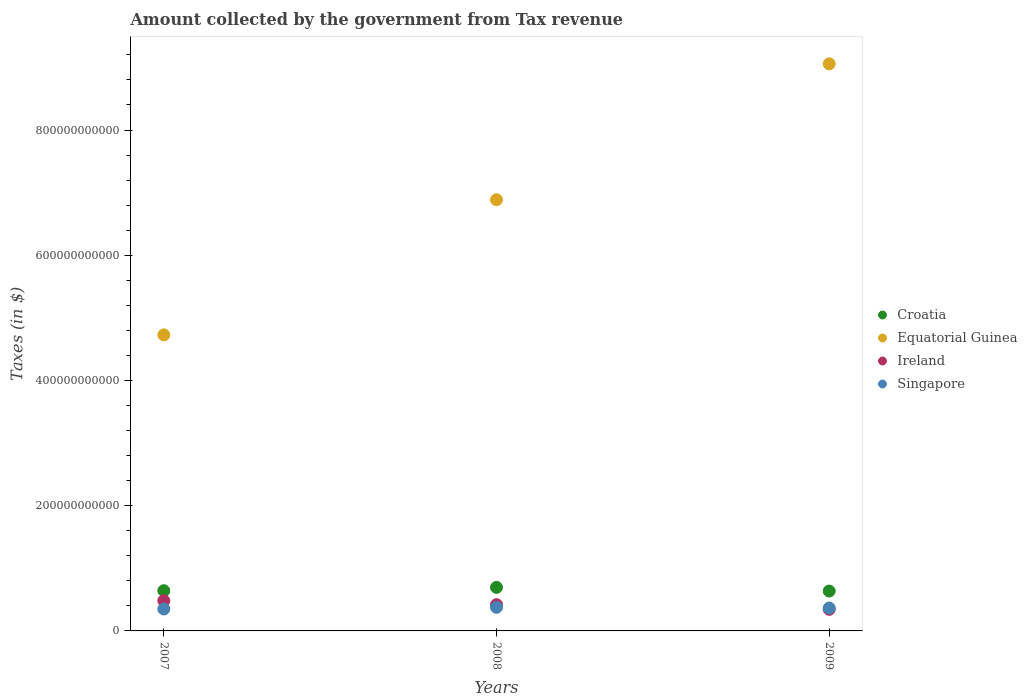What is the amount collected by the government from tax revenue in Singapore in 2009?
Make the answer very short. 3.66e+1. Across all years, what is the maximum amount collected by the government from tax revenue in Equatorial Guinea?
Your answer should be very brief. 9.06e+11. Across all years, what is the minimum amount collected by the government from tax revenue in Singapore?
Ensure brevity in your answer.  3.50e+1. In which year was the amount collected by the government from tax revenue in Ireland maximum?
Provide a short and direct response. 2007. In which year was the amount collected by the government from tax revenue in Ireland minimum?
Provide a succinct answer. 2009. What is the total amount collected by the government from tax revenue in Equatorial Guinea in the graph?
Make the answer very short. 2.07e+12. What is the difference between the amount collected by the government from tax revenue in Ireland in 2007 and that in 2009?
Your answer should be very brief. 1.39e+1. What is the difference between the amount collected by the government from tax revenue in Equatorial Guinea in 2008 and the amount collected by the government from tax revenue in Ireland in 2009?
Offer a very short reply. 6.54e+11. What is the average amount collected by the government from tax revenue in Singapore per year?
Give a very brief answer. 3.64e+1. In the year 2008, what is the difference between the amount collected by the government from tax revenue in Ireland and amount collected by the government from tax revenue in Croatia?
Provide a succinct answer. -2.77e+1. In how many years, is the amount collected by the government from tax revenue in Equatorial Guinea greater than 480000000000 $?
Your response must be concise. 2. What is the ratio of the amount collected by the government from tax revenue in Singapore in 2007 to that in 2009?
Provide a succinct answer. 0.96. Is the amount collected by the government from tax revenue in Ireland in 2007 less than that in 2008?
Provide a short and direct response. No. What is the difference between the highest and the second highest amount collected by the government from tax revenue in Croatia?
Your answer should be compact. 5.34e+09. What is the difference between the highest and the lowest amount collected by the government from tax revenue in Croatia?
Make the answer very short. 5.89e+09. In how many years, is the amount collected by the government from tax revenue in Croatia greater than the average amount collected by the government from tax revenue in Croatia taken over all years?
Your answer should be compact. 1. Is the sum of the amount collected by the government from tax revenue in Equatorial Guinea in 2007 and 2009 greater than the maximum amount collected by the government from tax revenue in Croatia across all years?
Your answer should be very brief. Yes. Is it the case that in every year, the sum of the amount collected by the government from tax revenue in Ireland and amount collected by the government from tax revenue in Equatorial Guinea  is greater than the sum of amount collected by the government from tax revenue in Croatia and amount collected by the government from tax revenue in Singapore?
Ensure brevity in your answer.  Yes. Is it the case that in every year, the sum of the amount collected by the government from tax revenue in Ireland and amount collected by the government from tax revenue in Singapore  is greater than the amount collected by the government from tax revenue in Equatorial Guinea?
Your answer should be compact. No. Is the amount collected by the government from tax revenue in Singapore strictly less than the amount collected by the government from tax revenue in Ireland over the years?
Make the answer very short. No. What is the difference between two consecutive major ticks on the Y-axis?
Your answer should be very brief. 2.00e+11. Are the values on the major ticks of Y-axis written in scientific E-notation?
Offer a terse response. No. Does the graph contain grids?
Your response must be concise. No. Where does the legend appear in the graph?
Ensure brevity in your answer.  Center right. What is the title of the graph?
Your answer should be very brief. Amount collected by the government from Tax revenue. Does "Latin America(all income levels)" appear as one of the legend labels in the graph?
Keep it short and to the point. No. What is the label or title of the Y-axis?
Offer a very short reply. Taxes (in $). What is the Taxes (in $) in Croatia in 2007?
Ensure brevity in your answer.  6.42e+1. What is the Taxes (in $) in Equatorial Guinea in 2007?
Your answer should be compact. 4.73e+11. What is the Taxes (in $) of Ireland in 2007?
Keep it short and to the point. 4.83e+1. What is the Taxes (in $) of Singapore in 2007?
Give a very brief answer. 3.50e+1. What is the Taxes (in $) in Croatia in 2008?
Offer a terse response. 6.96e+1. What is the Taxes (in $) of Equatorial Guinea in 2008?
Ensure brevity in your answer.  6.89e+11. What is the Taxes (in $) of Ireland in 2008?
Provide a succinct answer. 4.19e+1. What is the Taxes (in $) of Singapore in 2008?
Provide a succinct answer. 3.77e+1. What is the Taxes (in $) of Croatia in 2009?
Your answer should be compact. 6.37e+1. What is the Taxes (in $) in Equatorial Guinea in 2009?
Give a very brief answer. 9.06e+11. What is the Taxes (in $) of Ireland in 2009?
Your response must be concise. 3.45e+1. What is the Taxes (in $) in Singapore in 2009?
Give a very brief answer. 3.66e+1. Across all years, what is the maximum Taxes (in $) in Croatia?
Give a very brief answer. 6.96e+1. Across all years, what is the maximum Taxes (in $) of Equatorial Guinea?
Offer a very short reply. 9.06e+11. Across all years, what is the maximum Taxes (in $) in Ireland?
Your answer should be very brief. 4.83e+1. Across all years, what is the maximum Taxes (in $) of Singapore?
Your response must be concise. 3.77e+1. Across all years, what is the minimum Taxes (in $) of Croatia?
Make the answer very short. 6.37e+1. Across all years, what is the minimum Taxes (in $) of Equatorial Guinea?
Provide a short and direct response. 4.73e+11. Across all years, what is the minimum Taxes (in $) of Ireland?
Offer a very short reply. 3.45e+1. Across all years, what is the minimum Taxes (in $) of Singapore?
Your answer should be compact. 3.50e+1. What is the total Taxes (in $) in Croatia in the graph?
Provide a short and direct response. 1.97e+11. What is the total Taxes (in $) in Equatorial Guinea in the graph?
Offer a terse response. 2.07e+12. What is the total Taxes (in $) of Ireland in the graph?
Provide a short and direct response. 1.25e+11. What is the total Taxes (in $) of Singapore in the graph?
Offer a very short reply. 1.09e+11. What is the difference between the Taxes (in $) of Croatia in 2007 and that in 2008?
Give a very brief answer. -5.34e+09. What is the difference between the Taxes (in $) of Equatorial Guinea in 2007 and that in 2008?
Ensure brevity in your answer.  -2.16e+11. What is the difference between the Taxes (in $) of Ireland in 2007 and that in 2008?
Your answer should be very brief. 6.43e+09. What is the difference between the Taxes (in $) of Singapore in 2007 and that in 2008?
Offer a very short reply. -2.72e+09. What is the difference between the Taxes (in $) of Croatia in 2007 and that in 2009?
Offer a terse response. 5.56e+08. What is the difference between the Taxes (in $) of Equatorial Guinea in 2007 and that in 2009?
Your answer should be compact. -4.33e+11. What is the difference between the Taxes (in $) of Ireland in 2007 and that in 2009?
Make the answer very short. 1.39e+1. What is the difference between the Taxes (in $) of Singapore in 2007 and that in 2009?
Provide a succinct answer. -1.62e+09. What is the difference between the Taxes (in $) of Croatia in 2008 and that in 2009?
Offer a very short reply. 5.89e+09. What is the difference between the Taxes (in $) of Equatorial Guinea in 2008 and that in 2009?
Provide a short and direct response. -2.17e+11. What is the difference between the Taxes (in $) in Ireland in 2008 and that in 2009?
Provide a succinct answer. 7.44e+09. What is the difference between the Taxes (in $) in Singapore in 2008 and that in 2009?
Provide a succinct answer. 1.10e+09. What is the difference between the Taxes (in $) of Croatia in 2007 and the Taxes (in $) of Equatorial Guinea in 2008?
Offer a terse response. -6.24e+11. What is the difference between the Taxes (in $) in Croatia in 2007 and the Taxes (in $) in Ireland in 2008?
Ensure brevity in your answer.  2.23e+1. What is the difference between the Taxes (in $) in Croatia in 2007 and the Taxes (in $) in Singapore in 2008?
Make the answer very short. 2.66e+1. What is the difference between the Taxes (in $) in Equatorial Guinea in 2007 and the Taxes (in $) in Ireland in 2008?
Give a very brief answer. 4.31e+11. What is the difference between the Taxes (in $) in Equatorial Guinea in 2007 and the Taxes (in $) in Singapore in 2008?
Provide a short and direct response. 4.35e+11. What is the difference between the Taxes (in $) in Ireland in 2007 and the Taxes (in $) in Singapore in 2008?
Your answer should be compact. 1.06e+1. What is the difference between the Taxes (in $) of Croatia in 2007 and the Taxes (in $) of Equatorial Guinea in 2009?
Make the answer very short. -8.41e+11. What is the difference between the Taxes (in $) of Croatia in 2007 and the Taxes (in $) of Ireland in 2009?
Make the answer very short. 2.98e+1. What is the difference between the Taxes (in $) of Croatia in 2007 and the Taxes (in $) of Singapore in 2009?
Give a very brief answer. 2.77e+1. What is the difference between the Taxes (in $) of Equatorial Guinea in 2007 and the Taxes (in $) of Ireland in 2009?
Provide a succinct answer. 4.38e+11. What is the difference between the Taxes (in $) in Equatorial Guinea in 2007 and the Taxes (in $) in Singapore in 2009?
Ensure brevity in your answer.  4.36e+11. What is the difference between the Taxes (in $) of Ireland in 2007 and the Taxes (in $) of Singapore in 2009?
Ensure brevity in your answer.  1.17e+1. What is the difference between the Taxes (in $) in Croatia in 2008 and the Taxes (in $) in Equatorial Guinea in 2009?
Provide a short and direct response. -8.36e+11. What is the difference between the Taxes (in $) in Croatia in 2008 and the Taxes (in $) in Ireland in 2009?
Provide a short and direct response. 3.51e+1. What is the difference between the Taxes (in $) in Croatia in 2008 and the Taxes (in $) in Singapore in 2009?
Offer a very short reply. 3.30e+1. What is the difference between the Taxes (in $) of Equatorial Guinea in 2008 and the Taxes (in $) of Ireland in 2009?
Offer a terse response. 6.54e+11. What is the difference between the Taxes (in $) in Equatorial Guinea in 2008 and the Taxes (in $) in Singapore in 2009?
Offer a terse response. 6.52e+11. What is the difference between the Taxes (in $) in Ireland in 2008 and the Taxes (in $) in Singapore in 2009?
Your response must be concise. 5.31e+09. What is the average Taxes (in $) in Croatia per year?
Offer a terse response. 6.58e+1. What is the average Taxes (in $) in Equatorial Guinea per year?
Make the answer very short. 6.89e+11. What is the average Taxes (in $) of Ireland per year?
Keep it short and to the point. 4.16e+1. What is the average Taxes (in $) in Singapore per year?
Provide a succinct answer. 3.64e+1. In the year 2007, what is the difference between the Taxes (in $) in Croatia and Taxes (in $) in Equatorial Guinea?
Provide a short and direct response. -4.09e+11. In the year 2007, what is the difference between the Taxes (in $) of Croatia and Taxes (in $) of Ireland?
Your answer should be very brief. 1.59e+1. In the year 2007, what is the difference between the Taxes (in $) of Croatia and Taxes (in $) of Singapore?
Give a very brief answer. 2.93e+1. In the year 2007, what is the difference between the Taxes (in $) of Equatorial Guinea and Taxes (in $) of Ireland?
Ensure brevity in your answer.  4.24e+11. In the year 2007, what is the difference between the Taxes (in $) in Equatorial Guinea and Taxes (in $) in Singapore?
Provide a succinct answer. 4.38e+11. In the year 2007, what is the difference between the Taxes (in $) of Ireland and Taxes (in $) of Singapore?
Offer a very short reply. 1.34e+1. In the year 2008, what is the difference between the Taxes (in $) of Croatia and Taxes (in $) of Equatorial Guinea?
Provide a short and direct response. -6.19e+11. In the year 2008, what is the difference between the Taxes (in $) in Croatia and Taxes (in $) in Ireland?
Make the answer very short. 2.77e+1. In the year 2008, what is the difference between the Taxes (in $) in Croatia and Taxes (in $) in Singapore?
Offer a very short reply. 3.19e+1. In the year 2008, what is the difference between the Taxes (in $) in Equatorial Guinea and Taxes (in $) in Ireland?
Give a very brief answer. 6.47e+11. In the year 2008, what is the difference between the Taxes (in $) in Equatorial Guinea and Taxes (in $) in Singapore?
Your answer should be compact. 6.51e+11. In the year 2008, what is the difference between the Taxes (in $) of Ireland and Taxes (in $) of Singapore?
Provide a succinct answer. 4.21e+09. In the year 2009, what is the difference between the Taxes (in $) of Croatia and Taxes (in $) of Equatorial Guinea?
Make the answer very short. -8.42e+11. In the year 2009, what is the difference between the Taxes (in $) of Croatia and Taxes (in $) of Ireland?
Offer a terse response. 2.92e+1. In the year 2009, what is the difference between the Taxes (in $) in Croatia and Taxes (in $) in Singapore?
Offer a very short reply. 2.71e+1. In the year 2009, what is the difference between the Taxes (in $) of Equatorial Guinea and Taxes (in $) of Ireland?
Your answer should be very brief. 8.71e+11. In the year 2009, what is the difference between the Taxes (in $) of Equatorial Guinea and Taxes (in $) of Singapore?
Give a very brief answer. 8.69e+11. In the year 2009, what is the difference between the Taxes (in $) of Ireland and Taxes (in $) of Singapore?
Your answer should be very brief. -2.13e+09. What is the ratio of the Taxes (in $) in Croatia in 2007 to that in 2008?
Provide a succinct answer. 0.92. What is the ratio of the Taxes (in $) of Equatorial Guinea in 2007 to that in 2008?
Give a very brief answer. 0.69. What is the ratio of the Taxes (in $) of Ireland in 2007 to that in 2008?
Offer a very short reply. 1.15. What is the ratio of the Taxes (in $) in Singapore in 2007 to that in 2008?
Offer a terse response. 0.93. What is the ratio of the Taxes (in $) of Croatia in 2007 to that in 2009?
Make the answer very short. 1.01. What is the ratio of the Taxes (in $) in Equatorial Guinea in 2007 to that in 2009?
Provide a short and direct response. 0.52. What is the ratio of the Taxes (in $) in Ireland in 2007 to that in 2009?
Ensure brevity in your answer.  1.4. What is the ratio of the Taxes (in $) in Singapore in 2007 to that in 2009?
Your answer should be compact. 0.96. What is the ratio of the Taxes (in $) in Croatia in 2008 to that in 2009?
Offer a very short reply. 1.09. What is the ratio of the Taxes (in $) in Equatorial Guinea in 2008 to that in 2009?
Offer a terse response. 0.76. What is the ratio of the Taxes (in $) of Ireland in 2008 to that in 2009?
Provide a succinct answer. 1.22. What is the ratio of the Taxes (in $) of Singapore in 2008 to that in 2009?
Offer a very short reply. 1.03. What is the difference between the highest and the second highest Taxes (in $) in Croatia?
Provide a short and direct response. 5.34e+09. What is the difference between the highest and the second highest Taxes (in $) of Equatorial Guinea?
Your answer should be very brief. 2.17e+11. What is the difference between the highest and the second highest Taxes (in $) in Ireland?
Ensure brevity in your answer.  6.43e+09. What is the difference between the highest and the second highest Taxes (in $) of Singapore?
Provide a succinct answer. 1.10e+09. What is the difference between the highest and the lowest Taxes (in $) in Croatia?
Your answer should be very brief. 5.89e+09. What is the difference between the highest and the lowest Taxes (in $) in Equatorial Guinea?
Provide a succinct answer. 4.33e+11. What is the difference between the highest and the lowest Taxes (in $) in Ireland?
Give a very brief answer. 1.39e+1. What is the difference between the highest and the lowest Taxes (in $) of Singapore?
Your answer should be very brief. 2.72e+09. 